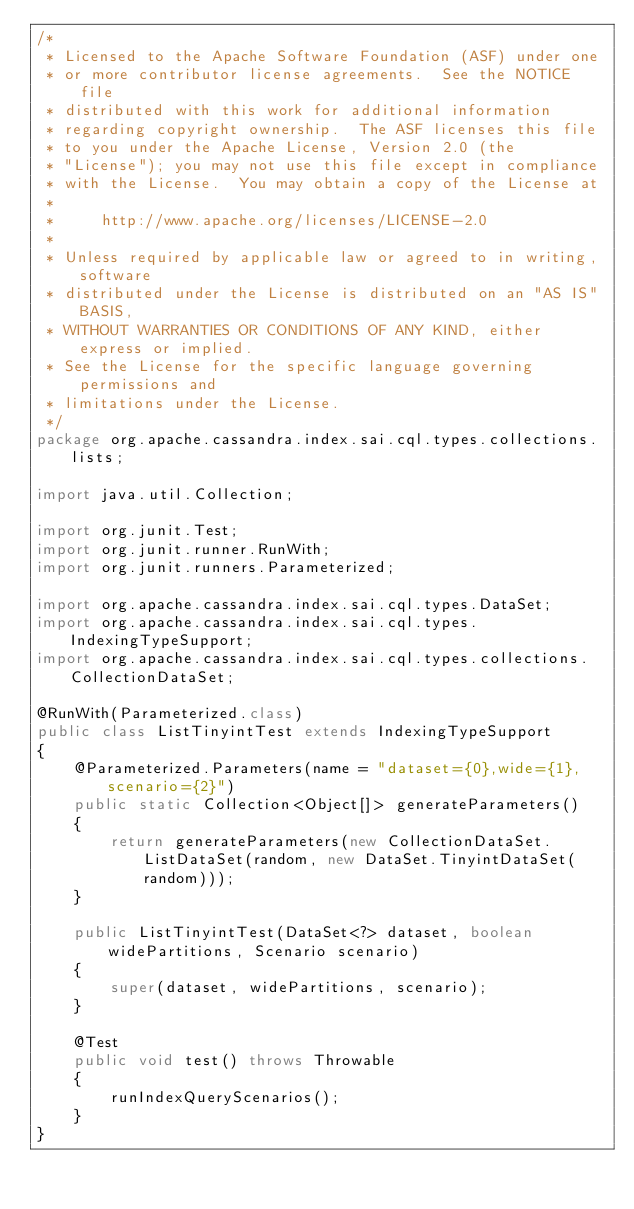<code> <loc_0><loc_0><loc_500><loc_500><_Java_>/*
 * Licensed to the Apache Software Foundation (ASF) under one
 * or more contributor license agreements.  See the NOTICE file
 * distributed with this work for additional information
 * regarding copyright ownership.  The ASF licenses this file
 * to you under the Apache License, Version 2.0 (the
 * "License"); you may not use this file except in compliance
 * with the License.  You may obtain a copy of the License at
 *
 *     http://www.apache.org/licenses/LICENSE-2.0
 *
 * Unless required by applicable law or agreed to in writing, software
 * distributed under the License is distributed on an "AS IS" BASIS,
 * WITHOUT WARRANTIES OR CONDITIONS OF ANY KIND, either express or implied.
 * See the License for the specific language governing permissions and
 * limitations under the License.
 */
package org.apache.cassandra.index.sai.cql.types.collections.lists;

import java.util.Collection;

import org.junit.Test;
import org.junit.runner.RunWith;
import org.junit.runners.Parameterized;

import org.apache.cassandra.index.sai.cql.types.DataSet;
import org.apache.cassandra.index.sai.cql.types.IndexingTypeSupport;
import org.apache.cassandra.index.sai.cql.types.collections.CollectionDataSet;

@RunWith(Parameterized.class)
public class ListTinyintTest extends IndexingTypeSupport
{
    @Parameterized.Parameters(name = "dataset={0},wide={1},scenario={2}")
    public static Collection<Object[]> generateParameters()
    {
        return generateParameters(new CollectionDataSet.ListDataSet(random, new DataSet.TinyintDataSet(random)));
    }

    public ListTinyintTest(DataSet<?> dataset, boolean widePartitions, Scenario scenario)
    {
        super(dataset, widePartitions, scenario);
    }

    @Test
    public void test() throws Throwable
    {
        runIndexQueryScenarios();
    }
}
</code> 